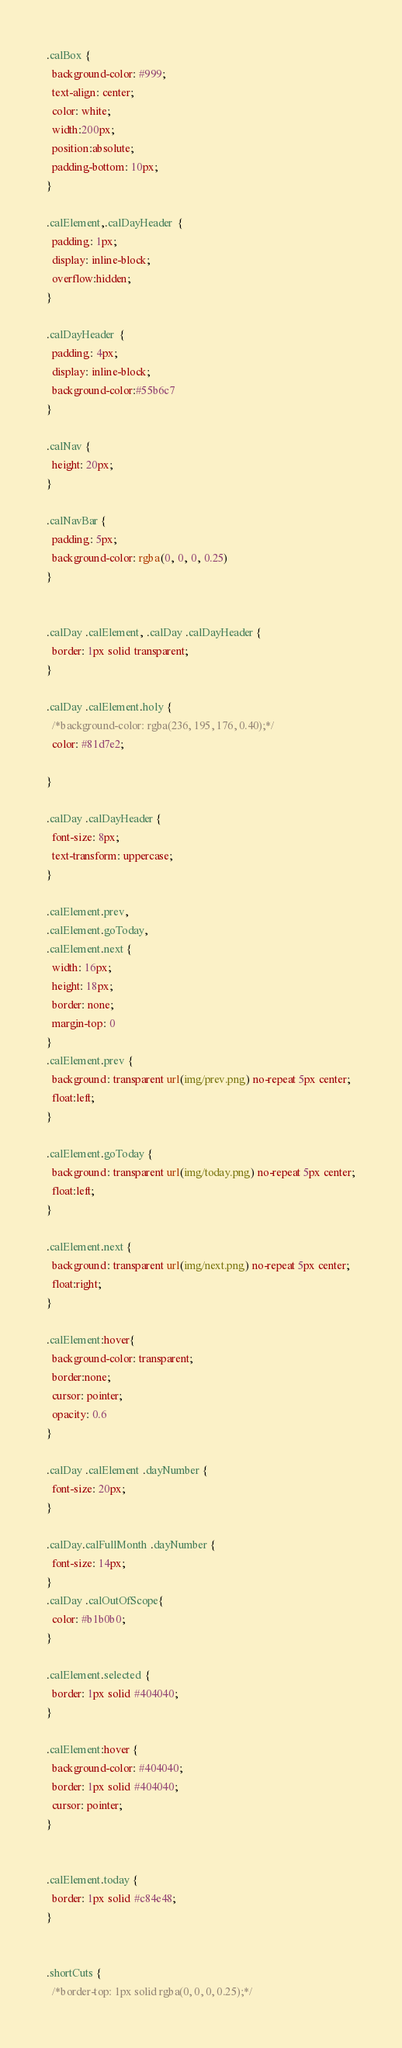<code> <loc_0><loc_0><loc_500><loc_500><_CSS_>.calBox {
  background-color: #999;
  text-align: center;
  color: white;
  width:200px;
  position:absolute;
  padding-bottom: 10px;
}

.calElement,.calDayHeader  {
  padding: 1px;
  display: inline-block;
  overflow:hidden;
}

.calDayHeader  {
  padding: 4px;
  display: inline-block;
  background-color:#55b6c7
}

.calNav {
  height: 20px;
}

.calNavBar {
  padding: 5px;
  background-color: rgba(0, 0, 0, 0.25)
}


.calDay .calElement, .calDay .calDayHeader {
  border: 1px solid transparent;
}

.calDay .calElement.holy {
  /*background-color: rgba(236, 195, 176, 0.40);*/
  color: #81d7e2;

}

.calDay .calDayHeader {
  font-size: 8px;
  text-transform: uppercase;
}

.calElement.prev,
.calElement.goToday,
.calElement.next {
  width: 16px;
  height: 18px;
  border: none;
  margin-top: 0
}
.calElement.prev {
  background: transparent url(img/prev.png) no-repeat 5px center;
  float:left;
}

.calElement.goToday {
  background: transparent url(img/today.png) no-repeat 5px center;
  float:left;
}

.calElement.next {
  background: transparent url(img/next.png) no-repeat 5px center;
  float:right;
}

.calElement:hover{
  background-color: transparent;
  border:none;
  cursor: pointer;
  opacity: 0.6
}

.calDay .calElement .dayNumber {
  font-size: 20px;
}

.calDay.calFullMonth .dayNumber {
  font-size: 14px;
}
.calDay .calOutOfScope{
  color: #b1b0b0;
}

.calElement.selected {
  border: 1px solid #404040;
}

.calElement:hover {
  background-color: #404040;
  border: 1px solid #404040;
  cursor: pointer;
}


.calElement.today {
  border: 1px solid #c84e48;
}


.shortCuts {
  /*border-top: 1px solid rgba(0, 0, 0, 0.25);*/</code> 